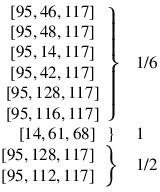Convert formula to latex. <formula><loc_0><loc_0><loc_500><loc_500>\begin{array} { r l r } { \begin{array} { c } { \left [ 9 5 , 4 6 , 1 1 7 \right ] } \\ { \left [ 9 5 , 4 8 , 1 1 7 \right ] } \\ { \left [ 9 5 , 1 4 , 1 1 7 \right ] } \\ { \left [ 9 5 , 4 2 , 1 1 7 \right ] } \\ { \left [ 9 5 , 1 2 8 , 1 1 7 \right ] } \\ { \left [ 9 5 , 1 1 6 , 1 1 7 \right ] } \end{array} \right \} } & 1 / 6 } \\ { \left [ 1 4 , 6 1 , 6 8 \right ] \, \right \} \, } & 1 } \\ { \begin{array} { c } { \left [ 9 5 , 1 2 8 , 1 1 7 \right ] } \\ { \left [ 9 5 , 1 1 2 , 1 1 7 \right ] } \end{array} \right \} } & 1 / 2 } \end{array}</formula> 